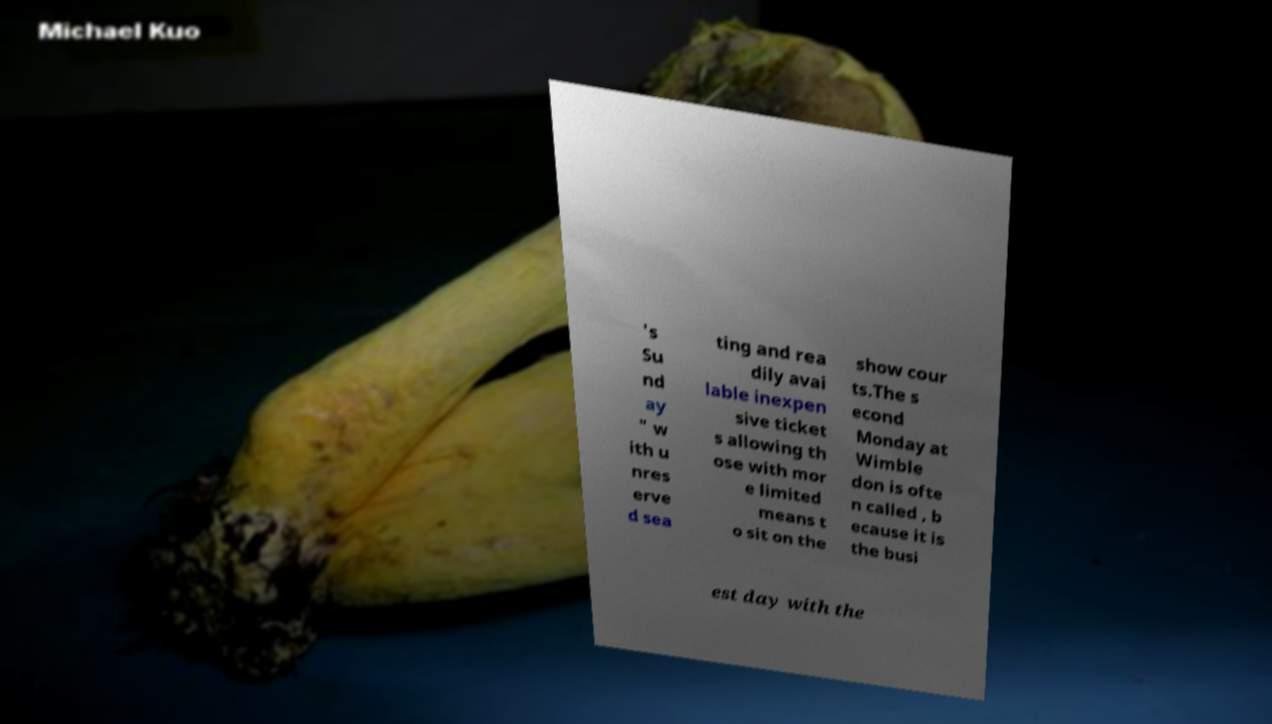Can you accurately transcribe the text from the provided image for me? 's Su nd ay " w ith u nres erve d sea ting and rea dily avai lable inexpen sive ticket s allowing th ose with mor e limited means t o sit on the show cour ts.The s econd Monday at Wimble don is ofte n called , b ecause it is the busi est day with the 